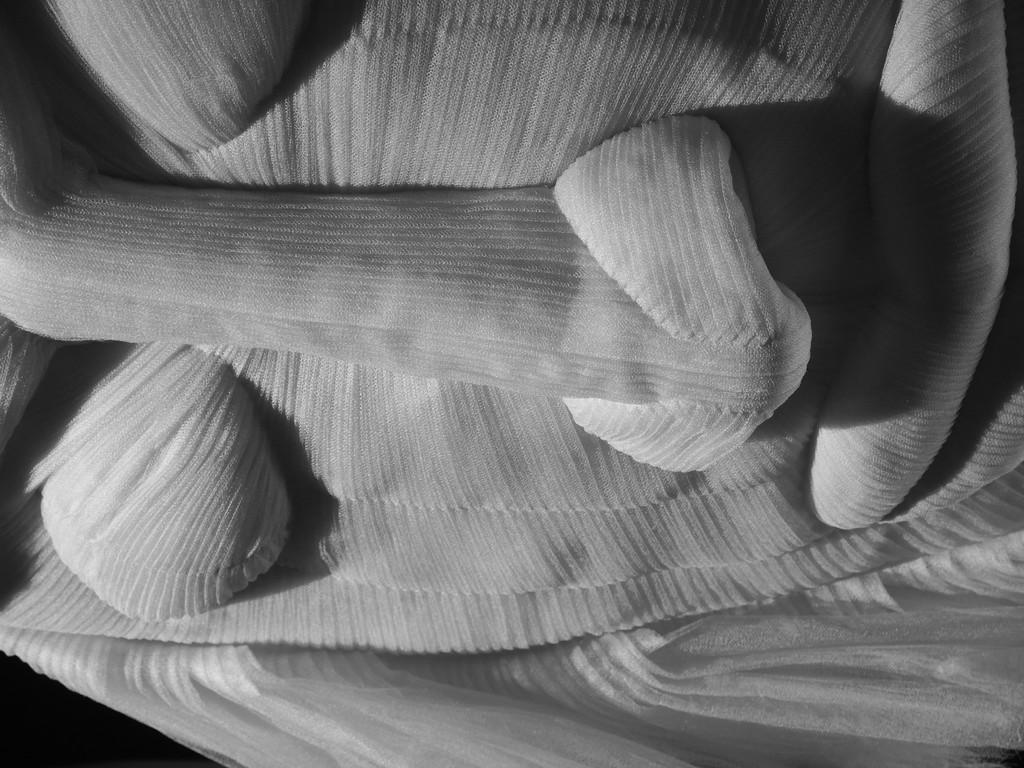What type of object is in the image? There is a toy in the image. What material is the toy made of? The toy is made up of cloth. What facial features does the toy have? The toy has eyes, nose, and mouth. What type of print can be seen on the bag in the image? There is no bag present in the image, and therefore no print to observe. 